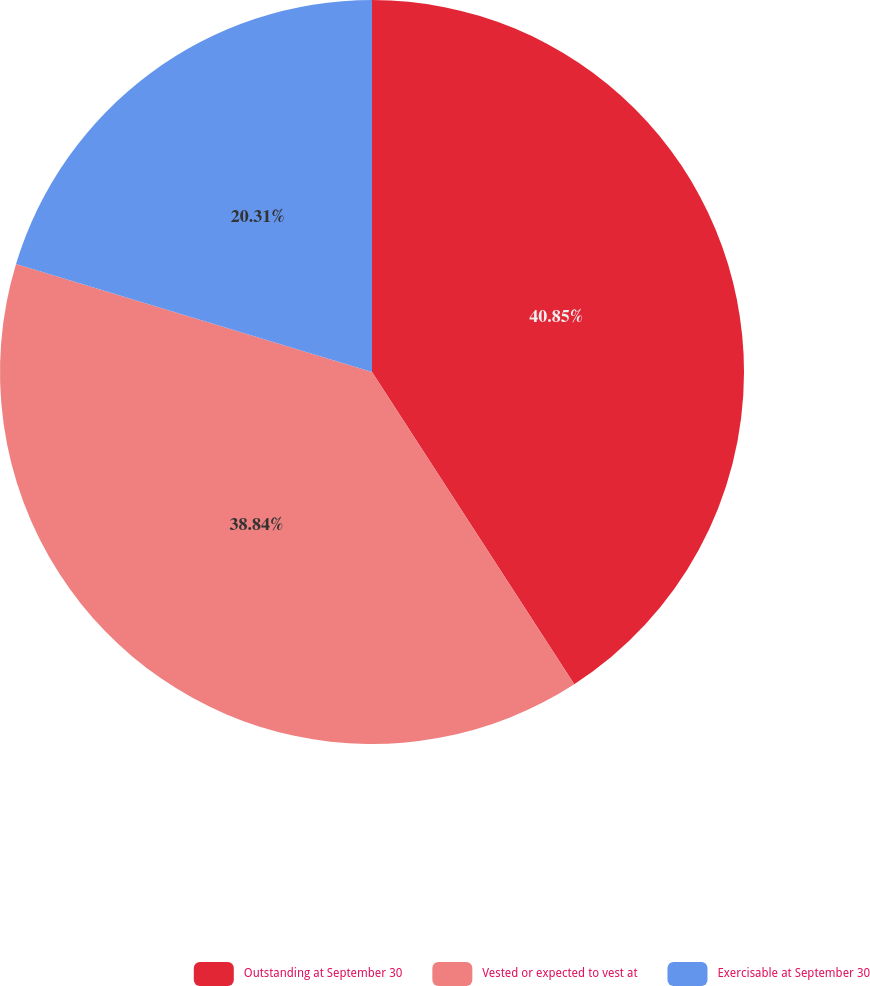<chart> <loc_0><loc_0><loc_500><loc_500><pie_chart><fcel>Outstanding at September 30<fcel>Vested or expected to vest at<fcel>Exercisable at September 30<nl><fcel>40.85%<fcel>38.84%<fcel>20.31%<nl></chart> 